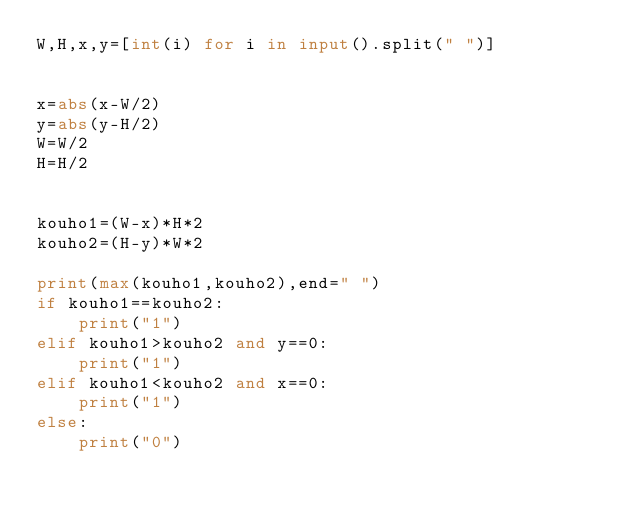Convert code to text. <code><loc_0><loc_0><loc_500><loc_500><_Python_>W,H,x,y=[int(i) for i in input().split(" ")]


x=abs(x-W/2)
y=abs(y-H/2)
W=W/2
H=H/2


kouho1=(W-x)*H*2
kouho2=(H-y)*W*2

print(max(kouho1,kouho2),end=" ")
if kouho1==kouho2:
    print("1")
elif kouho1>kouho2 and y==0:
    print("1")
elif kouho1<kouho2 and x==0:
    print("1")
else:
    print("0")
</code> 